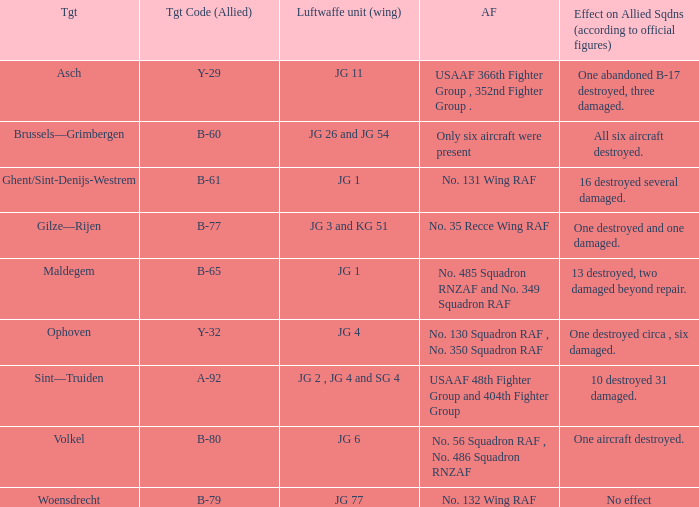Which allied force aimed at woensdrecht? No. 132 Wing RAF. 